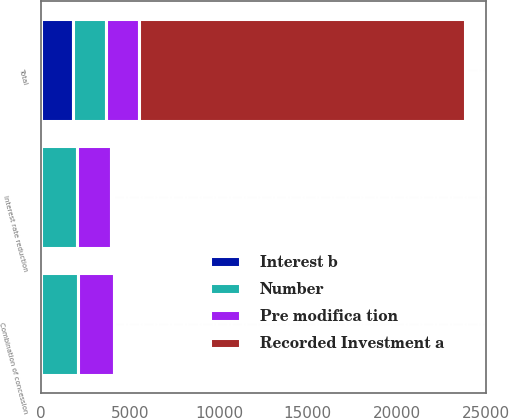<chart> <loc_0><loc_0><loc_500><loc_500><stacked_bar_chart><ecel><fcel>Combination of concession<fcel>Interest rate reduction<fcel>Total<nl><fcel>Interest b<fcel>3<fcel>14<fcel>1780<nl><fcel>Pre modifica tion<fcel>2049<fcel>1926<fcel>1853<nl><fcel>Number<fcel>2046<fcel>1991<fcel>1853<nl><fcel>Recorded Investment a<fcel>3<fcel>65<fcel>18333<nl></chart> 